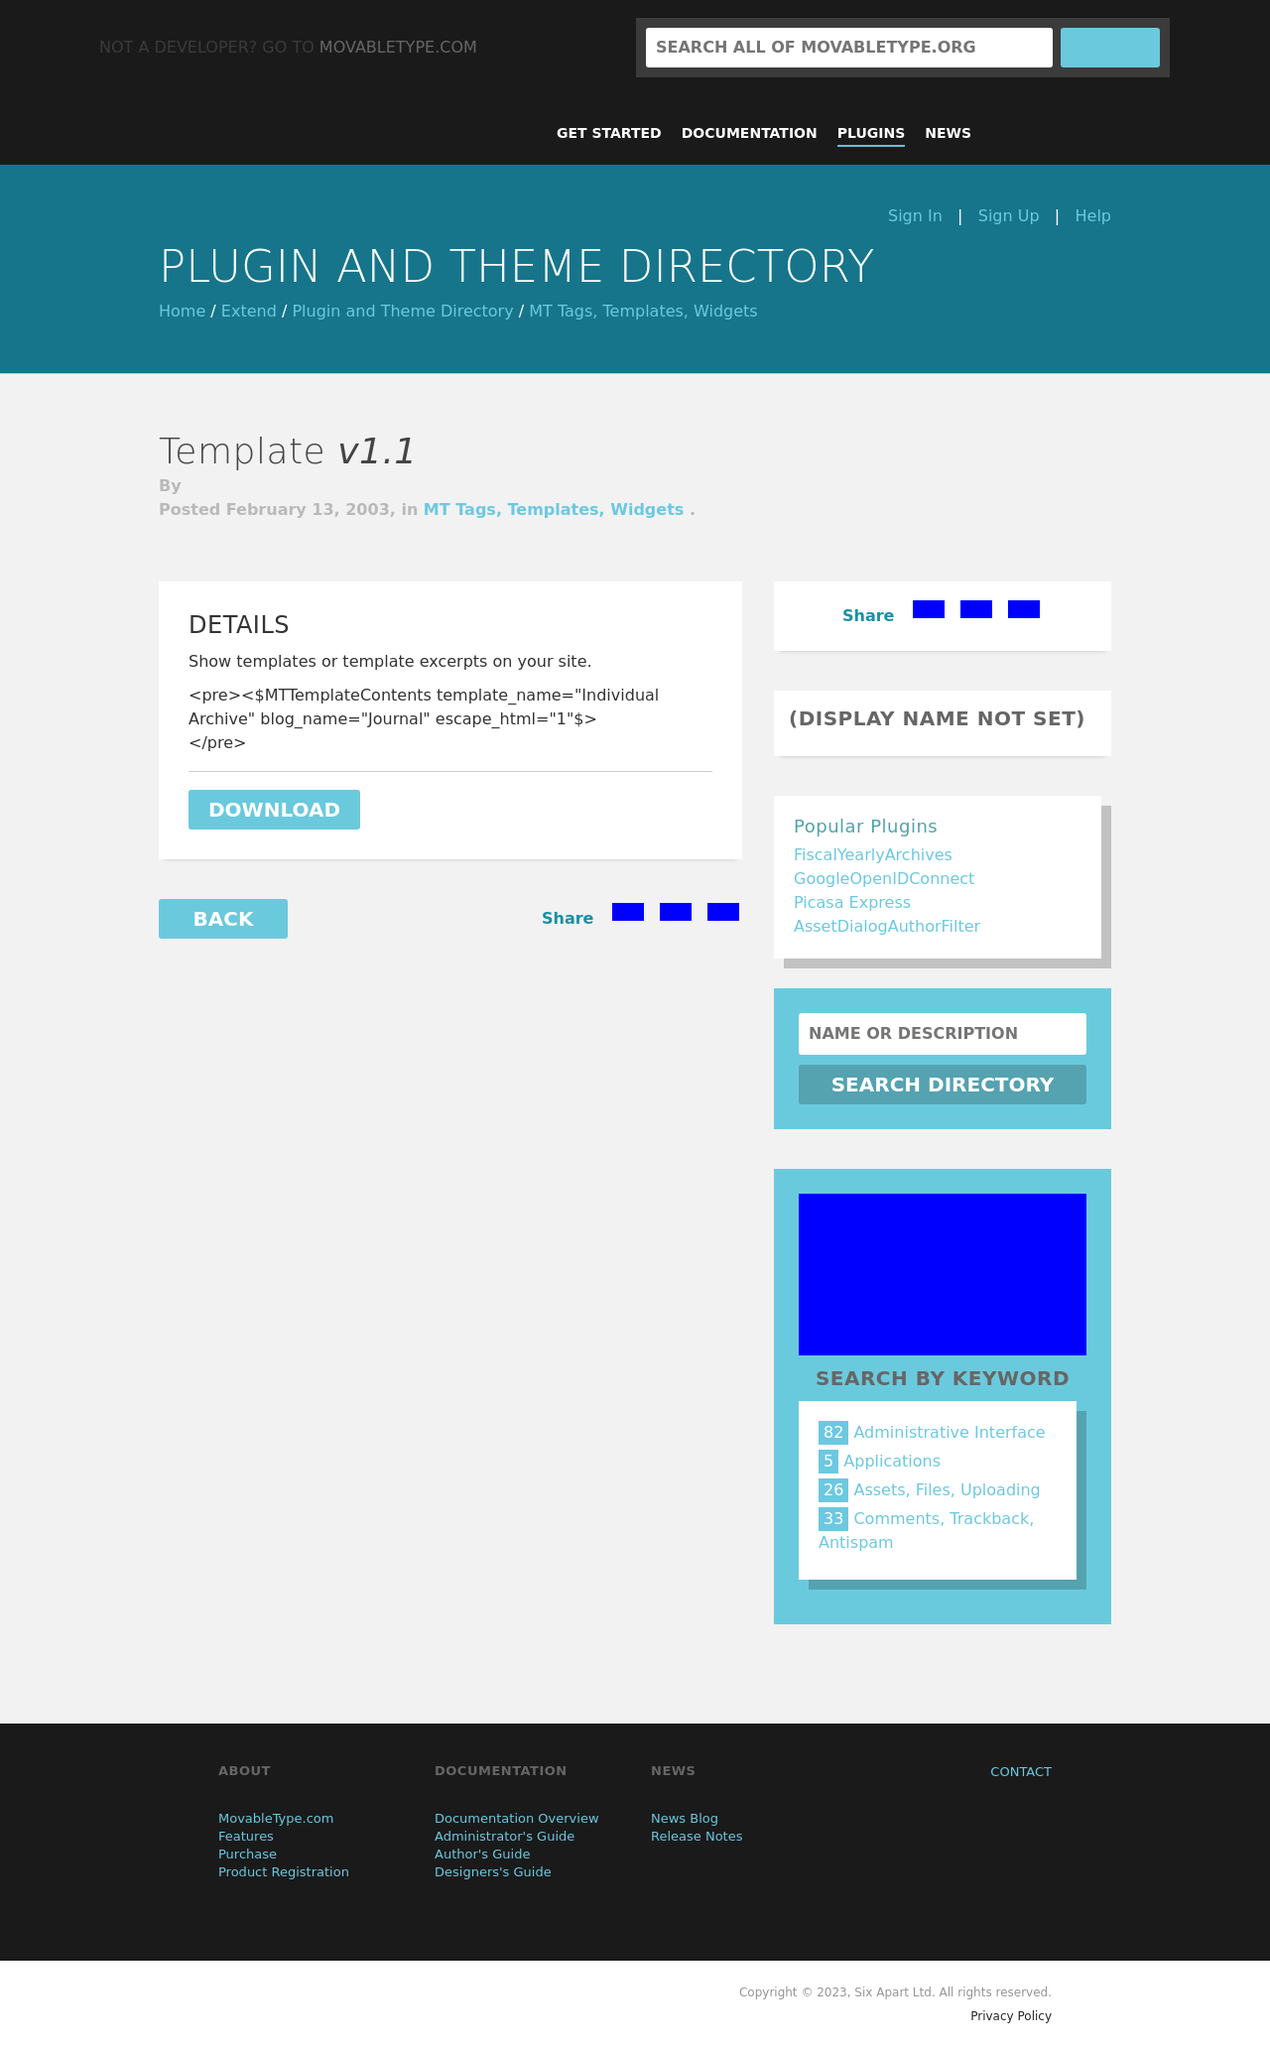What would be the steps to add content like the 'Search by Keyword' section in HTML? To add a 'Search by Keyword' section in HTML, start with a <section> or <div> container and give it a clear id or class name for styling. Inside, use a <form> element with a <label> for accessibility, and an <input> element of type 'text' for the search input. Add a <button> or <input> of type 'submit' for the search action. To display keywords, use an unordered list <ul> with <li> items, each containing an <a> tag for interactivity. You can group keywords with similar classes for styling and include a <span> to show the keyword count. 